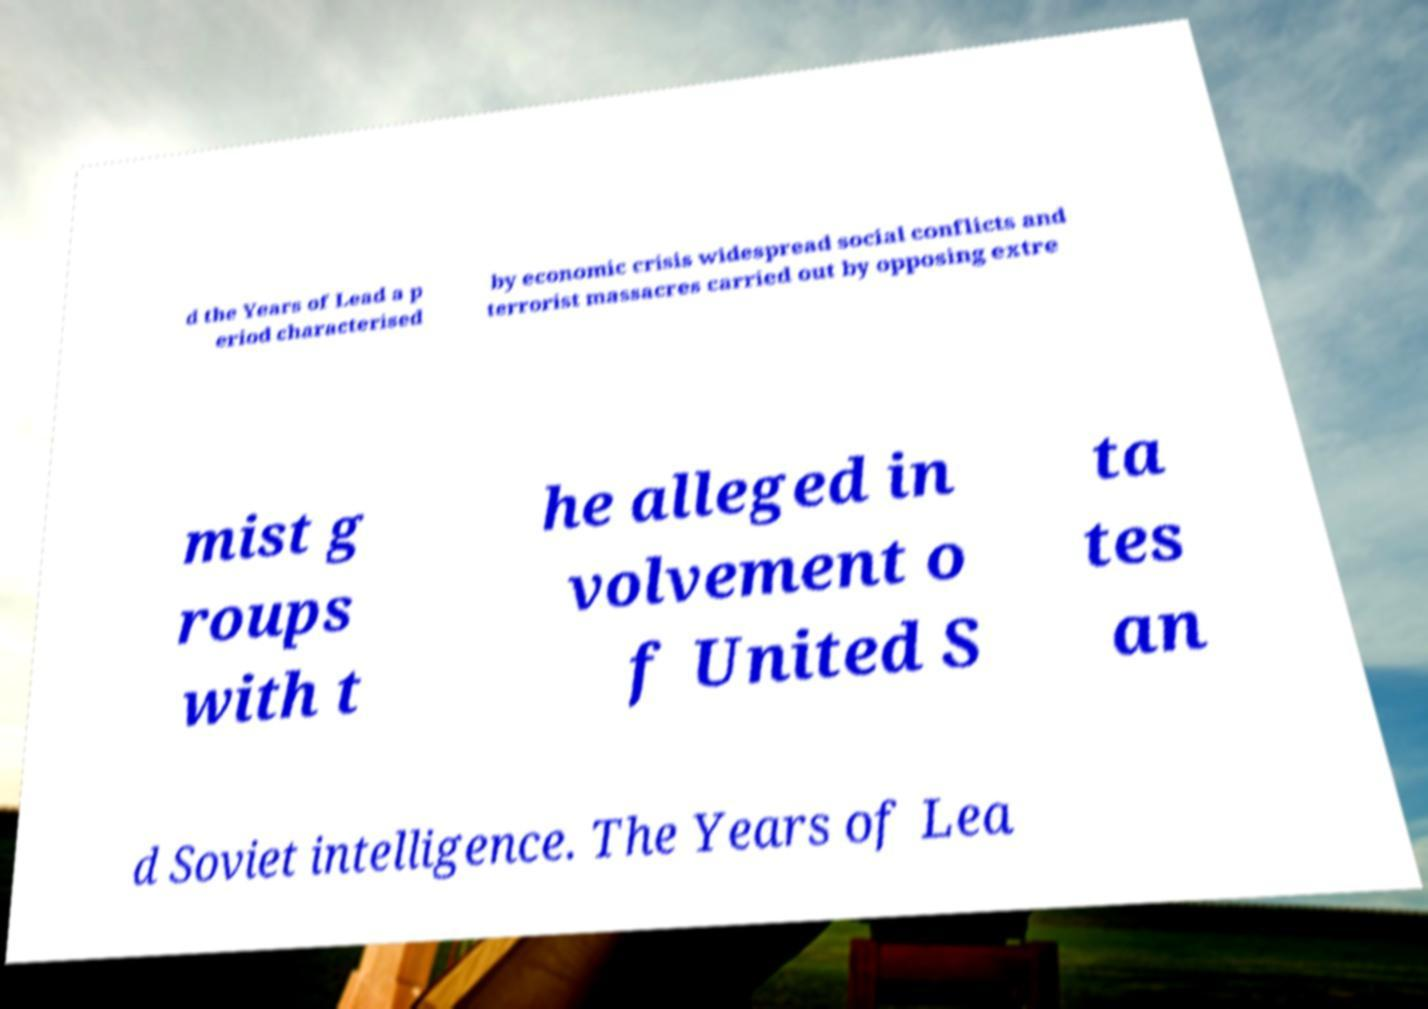For documentation purposes, I need the text within this image transcribed. Could you provide that? d the Years of Lead a p eriod characterised by economic crisis widespread social conflicts and terrorist massacres carried out by opposing extre mist g roups with t he alleged in volvement o f United S ta tes an d Soviet intelligence. The Years of Lea 